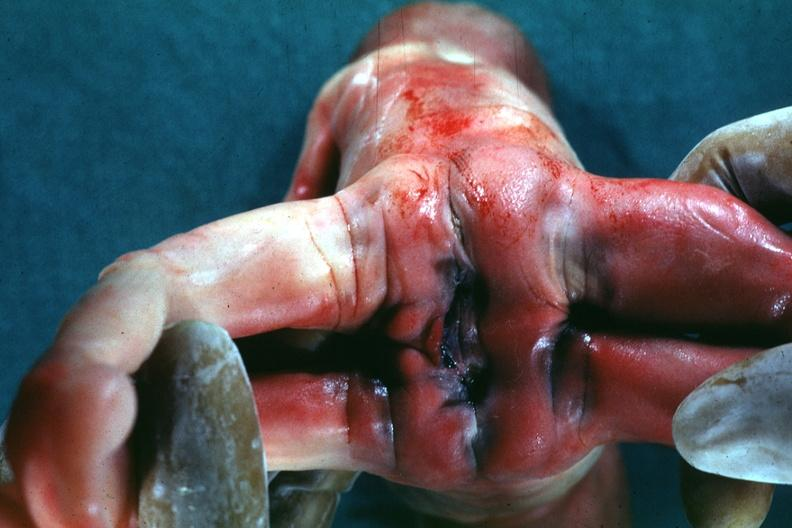what does this image show?
Answer the question using a single word or phrase. Joined anterior at chest and abdomen view from buttocks 